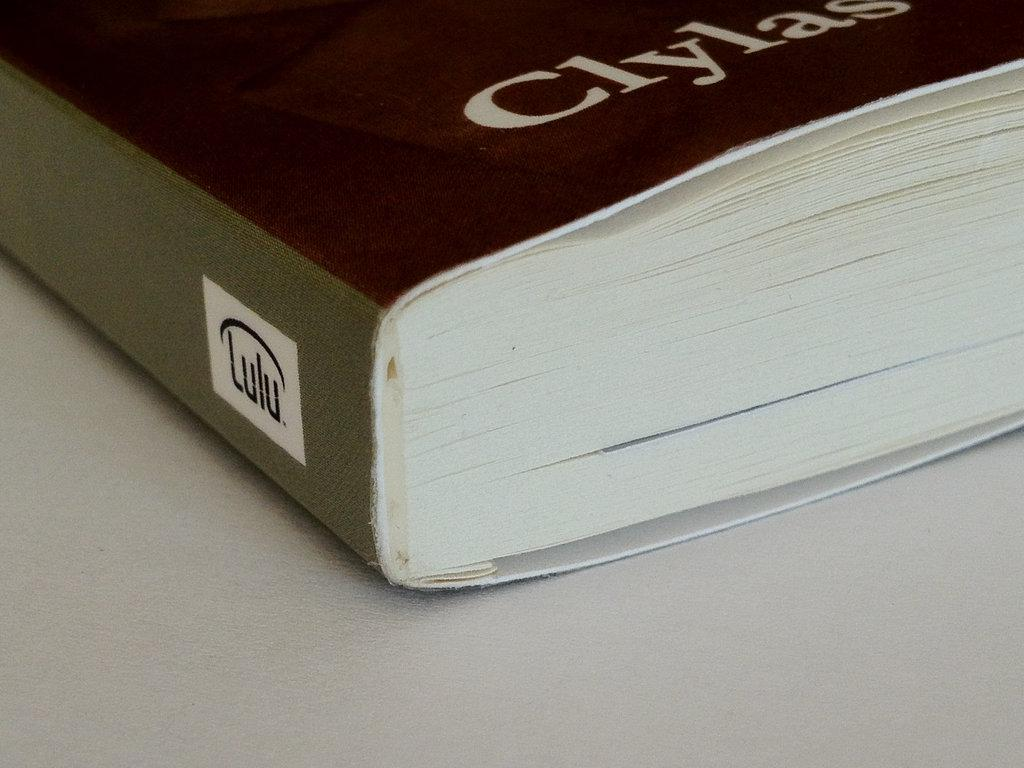<image>
Relay a brief, clear account of the picture shown. Lulu publishing is advertised on the side of this book. 